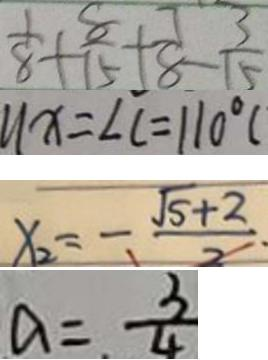Convert formula to latex. <formula><loc_0><loc_0><loc_500><loc_500>\frac { 1 } { 8 } + \frac { 8 } { 1 5 } + \frac { 7 } { 8 } - \frac { 3 } { 5 } 
 1 1 x = \angle C = 1 1 0 ^ { \circ } ( 
 x _ { 2 } = - \frac { \sqrt { 5 } + 2 } { 2 } . 
 a = \frac { 3 } { 4 }</formula> 